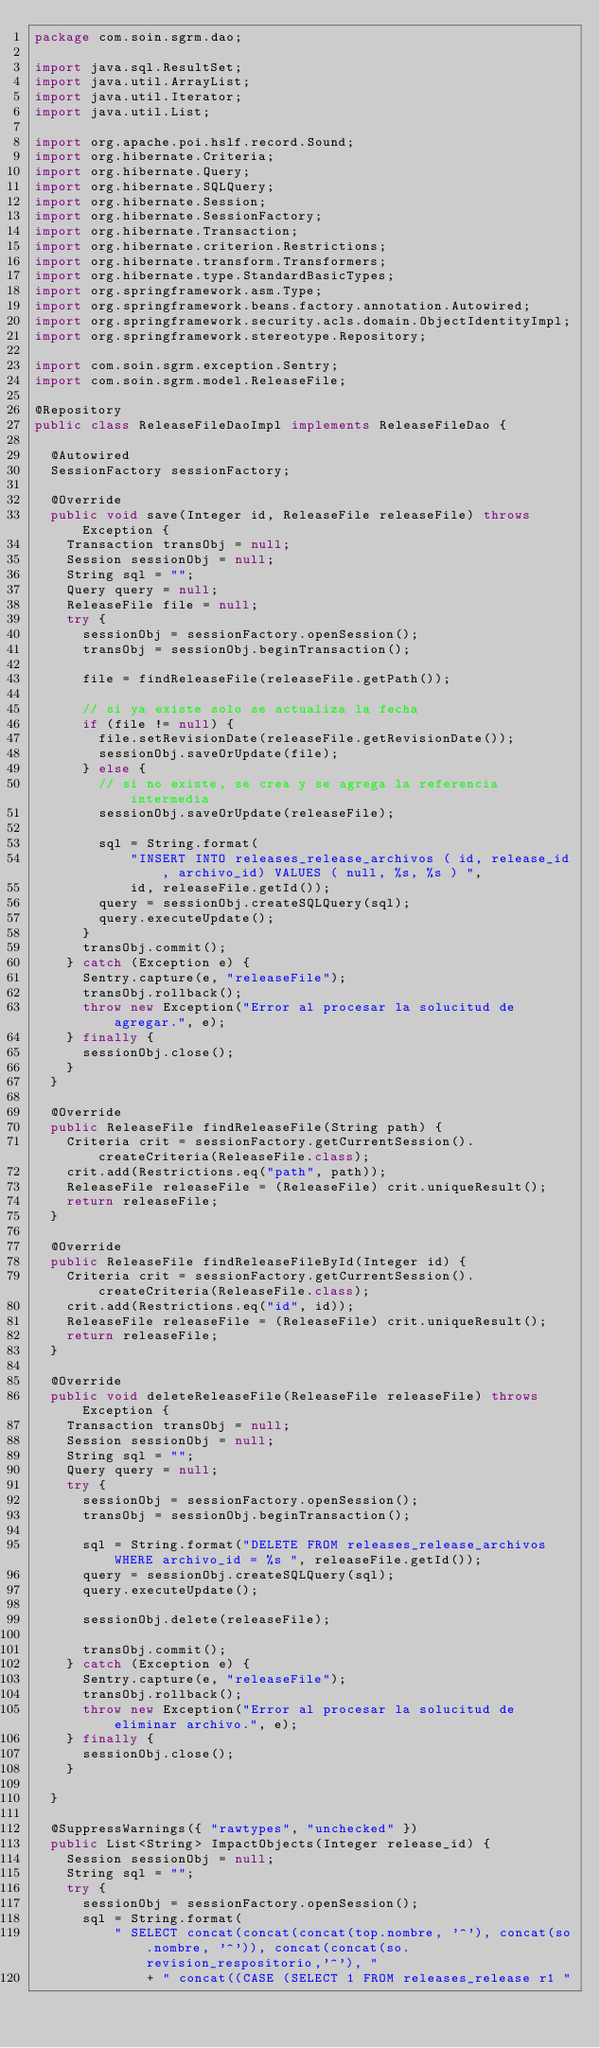Convert code to text. <code><loc_0><loc_0><loc_500><loc_500><_Java_>package com.soin.sgrm.dao;

import java.sql.ResultSet;
import java.util.ArrayList;
import java.util.Iterator;
import java.util.List;

import org.apache.poi.hslf.record.Sound;
import org.hibernate.Criteria;
import org.hibernate.Query;
import org.hibernate.SQLQuery;
import org.hibernate.Session;
import org.hibernate.SessionFactory;
import org.hibernate.Transaction;
import org.hibernate.criterion.Restrictions;
import org.hibernate.transform.Transformers;
import org.hibernate.type.StandardBasicTypes;
import org.springframework.asm.Type;
import org.springframework.beans.factory.annotation.Autowired;
import org.springframework.security.acls.domain.ObjectIdentityImpl;
import org.springframework.stereotype.Repository;

import com.soin.sgrm.exception.Sentry;
import com.soin.sgrm.model.ReleaseFile;

@Repository
public class ReleaseFileDaoImpl implements ReleaseFileDao {

	@Autowired
	SessionFactory sessionFactory;

	@Override
	public void save(Integer id, ReleaseFile releaseFile) throws Exception {
		Transaction transObj = null;
		Session sessionObj = null;
		String sql = "";
		Query query = null;
		ReleaseFile file = null;
		try {
			sessionObj = sessionFactory.openSession();
			transObj = sessionObj.beginTransaction();

			file = findReleaseFile(releaseFile.getPath());

			// si ya existe solo se actualiza la fecha
			if (file != null) {
				file.setRevisionDate(releaseFile.getRevisionDate());
				sessionObj.saveOrUpdate(file);
			} else {
				// si no existe, se crea y se agrega la referencia intermedia
				sessionObj.saveOrUpdate(releaseFile);

				sql = String.format(
						"INSERT INTO releases_release_archivos ( id, release_id, archivo_id) VALUES ( null, %s, %s ) ",
						id, releaseFile.getId());
				query = sessionObj.createSQLQuery(sql);
				query.executeUpdate();
			}
			transObj.commit();
		} catch (Exception e) {
			Sentry.capture(e, "releaseFile");
			transObj.rollback();
			throw new Exception("Error al procesar la solucitud de agregar.", e);
		} finally {
			sessionObj.close();
		}
	}

	@Override
	public ReleaseFile findReleaseFile(String path) {
		Criteria crit = sessionFactory.getCurrentSession().createCriteria(ReleaseFile.class);
		crit.add(Restrictions.eq("path", path));
		ReleaseFile releaseFile = (ReleaseFile) crit.uniqueResult();
		return releaseFile;
	}

	@Override
	public ReleaseFile findReleaseFileById(Integer id) {
		Criteria crit = sessionFactory.getCurrentSession().createCriteria(ReleaseFile.class);
		crit.add(Restrictions.eq("id", id));
		ReleaseFile releaseFile = (ReleaseFile) crit.uniqueResult();
		return releaseFile;
	}

	@Override
	public void deleteReleaseFile(ReleaseFile releaseFile) throws Exception {
		Transaction transObj = null;
		Session sessionObj = null;
		String sql = "";
		Query query = null;
		try {
			sessionObj = sessionFactory.openSession();
			transObj = sessionObj.beginTransaction();

			sql = String.format("DELETE FROM releases_release_archivos WHERE archivo_id = %s ", releaseFile.getId());
			query = sessionObj.createSQLQuery(sql);
			query.executeUpdate();

			sessionObj.delete(releaseFile);

			transObj.commit();
		} catch (Exception e) {
			Sentry.capture(e, "releaseFile");
			transObj.rollback();
			throw new Exception("Error al procesar la solucitud de eliminar archivo.", e);
		} finally {
			sessionObj.close();
		}

	}

	@SuppressWarnings({ "rawtypes", "unchecked" })
	public List<String> ImpactObjects(Integer release_id) {
		Session sessionObj = null;
		String sql = "";
		try {
			sessionObj = sessionFactory.openSession();
			sql = String.format(
					" SELECT concat(concat(concat(top.nombre, '^'), concat(so.nombre, '^')), concat(concat(so.revision_respositorio,'^'), "
							+ " concat((CASE (SELECT 1 FROM releases_release r1 "</code> 